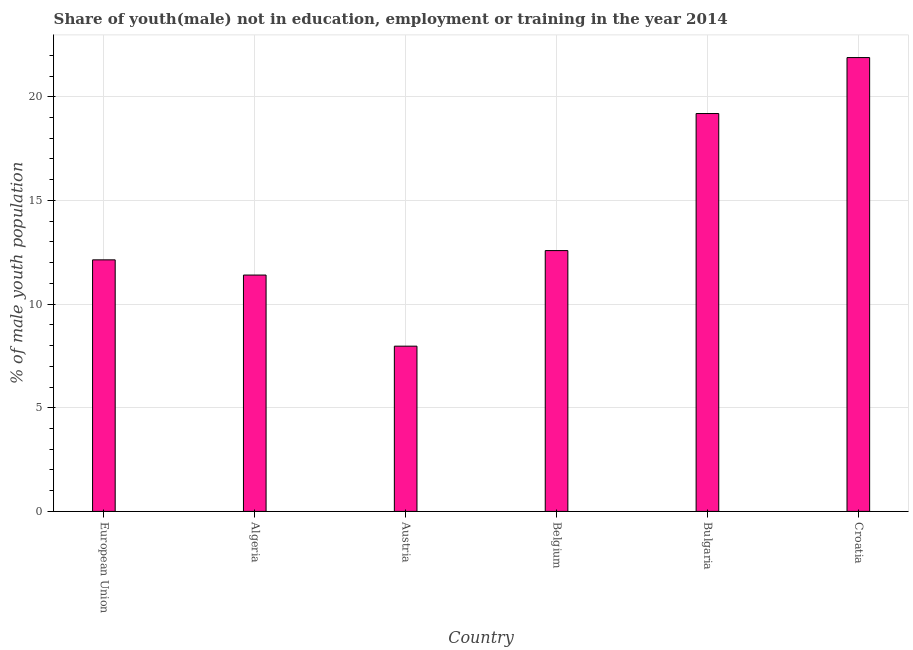Does the graph contain any zero values?
Provide a short and direct response. No. Does the graph contain grids?
Make the answer very short. Yes. What is the title of the graph?
Your response must be concise. Share of youth(male) not in education, employment or training in the year 2014. What is the label or title of the X-axis?
Make the answer very short. Country. What is the label or title of the Y-axis?
Give a very brief answer. % of male youth population. What is the unemployed male youth population in Belgium?
Ensure brevity in your answer.  12.58. Across all countries, what is the maximum unemployed male youth population?
Your answer should be compact. 21.89. Across all countries, what is the minimum unemployed male youth population?
Give a very brief answer. 7.97. In which country was the unemployed male youth population maximum?
Offer a terse response. Croatia. What is the sum of the unemployed male youth population?
Ensure brevity in your answer.  85.16. What is the difference between the unemployed male youth population in Algeria and Bulgaria?
Provide a short and direct response. -7.79. What is the average unemployed male youth population per country?
Keep it short and to the point. 14.19. What is the median unemployed male youth population?
Make the answer very short. 12.36. In how many countries, is the unemployed male youth population greater than 17 %?
Keep it short and to the point. 2. What is the ratio of the unemployed male youth population in Austria to that in Croatia?
Your answer should be compact. 0.36. Is the unemployed male youth population in Algeria less than that in European Union?
Your response must be concise. Yes. What is the difference between the highest and the second highest unemployed male youth population?
Offer a terse response. 2.7. What is the difference between the highest and the lowest unemployed male youth population?
Your response must be concise. 13.92. In how many countries, is the unemployed male youth population greater than the average unemployed male youth population taken over all countries?
Ensure brevity in your answer.  2. How many bars are there?
Provide a succinct answer. 6. What is the difference between two consecutive major ticks on the Y-axis?
Your response must be concise. 5. What is the % of male youth population of European Union?
Keep it short and to the point. 12.13. What is the % of male youth population in Algeria?
Provide a succinct answer. 11.4. What is the % of male youth population of Austria?
Provide a short and direct response. 7.97. What is the % of male youth population of Belgium?
Make the answer very short. 12.58. What is the % of male youth population of Bulgaria?
Keep it short and to the point. 19.19. What is the % of male youth population of Croatia?
Your answer should be compact. 21.89. What is the difference between the % of male youth population in European Union and Algeria?
Provide a short and direct response. 0.73. What is the difference between the % of male youth population in European Union and Austria?
Keep it short and to the point. 4.16. What is the difference between the % of male youth population in European Union and Belgium?
Offer a terse response. -0.45. What is the difference between the % of male youth population in European Union and Bulgaria?
Your response must be concise. -7.06. What is the difference between the % of male youth population in European Union and Croatia?
Give a very brief answer. -9.76. What is the difference between the % of male youth population in Algeria and Austria?
Provide a short and direct response. 3.43. What is the difference between the % of male youth population in Algeria and Belgium?
Provide a short and direct response. -1.18. What is the difference between the % of male youth population in Algeria and Bulgaria?
Your response must be concise. -7.79. What is the difference between the % of male youth population in Algeria and Croatia?
Offer a terse response. -10.49. What is the difference between the % of male youth population in Austria and Belgium?
Ensure brevity in your answer.  -4.61. What is the difference between the % of male youth population in Austria and Bulgaria?
Offer a very short reply. -11.22. What is the difference between the % of male youth population in Austria and Croatia?
Ensure brevity in your answer.  -13.92. What is the difference between the % of male youth population in Belgium and Bulgaria?
Ensure brevity in your answer.  -6.61. What is the difference between the % of male youth population in Belgium and Croatia?
Keep it short and to the point. -9.31. What is the difference between the % of male youth population in Bulgaria and Croatia?
Your answer should be compact. -2.7. What is the ratio of the % of male youth population in European Union to that in Algeria?
Ensure brevity in your answer.  1.06. What is the ratio of the % of male youth population in European Union to that in Austria?
Make the answer very short. 1.52. What is the ratio of the % of male youth population in European Union to that in Bulgaria?
Offer a very short reply. 0.63. What is the ratio of the % of male youth population in European Union to that in Croatia?
Ensure brevity in your answer.  0.55. What is the ratio of the % of male youth population in Algeria to that in Austria?
Provide a short and direct response. 1.43. What is the ratio of the % of male youth population in Algeria to that in Belgium?
Provide a succinct answer. 0.91. What is the ratio of the % of male youth population in Algeria to that in Bulgaria?
Offer a very short reply. 0.59. What is the ratio of the % of male youth population in Algeria to that in Croatia?
Provide a succinct answer. 0.52. What is the ratio of the % of male youth population in Austria to that in Belgium?
Offer a terse response. 0.63. What is the ratio of the % of male youth population in Austria to that in Bulgaria?
Keep it short and to the point. 0.41. What is the ratio of the % of male youth population in Austria to that in Croatia?
Your answer should be compact. 0.36. What is the ratio of the % of male youth population in Belgium to that in Bulgaria?
Your response must be concise. 0.66. What is the ratio of the % of male youth population in Belgium to that in Croatia?
Offer a very short reply. 0.57. What is the ratio of the % of male youth population in Bulgaria to that in Croatia?
Provide a short and direct response. 0.88. 